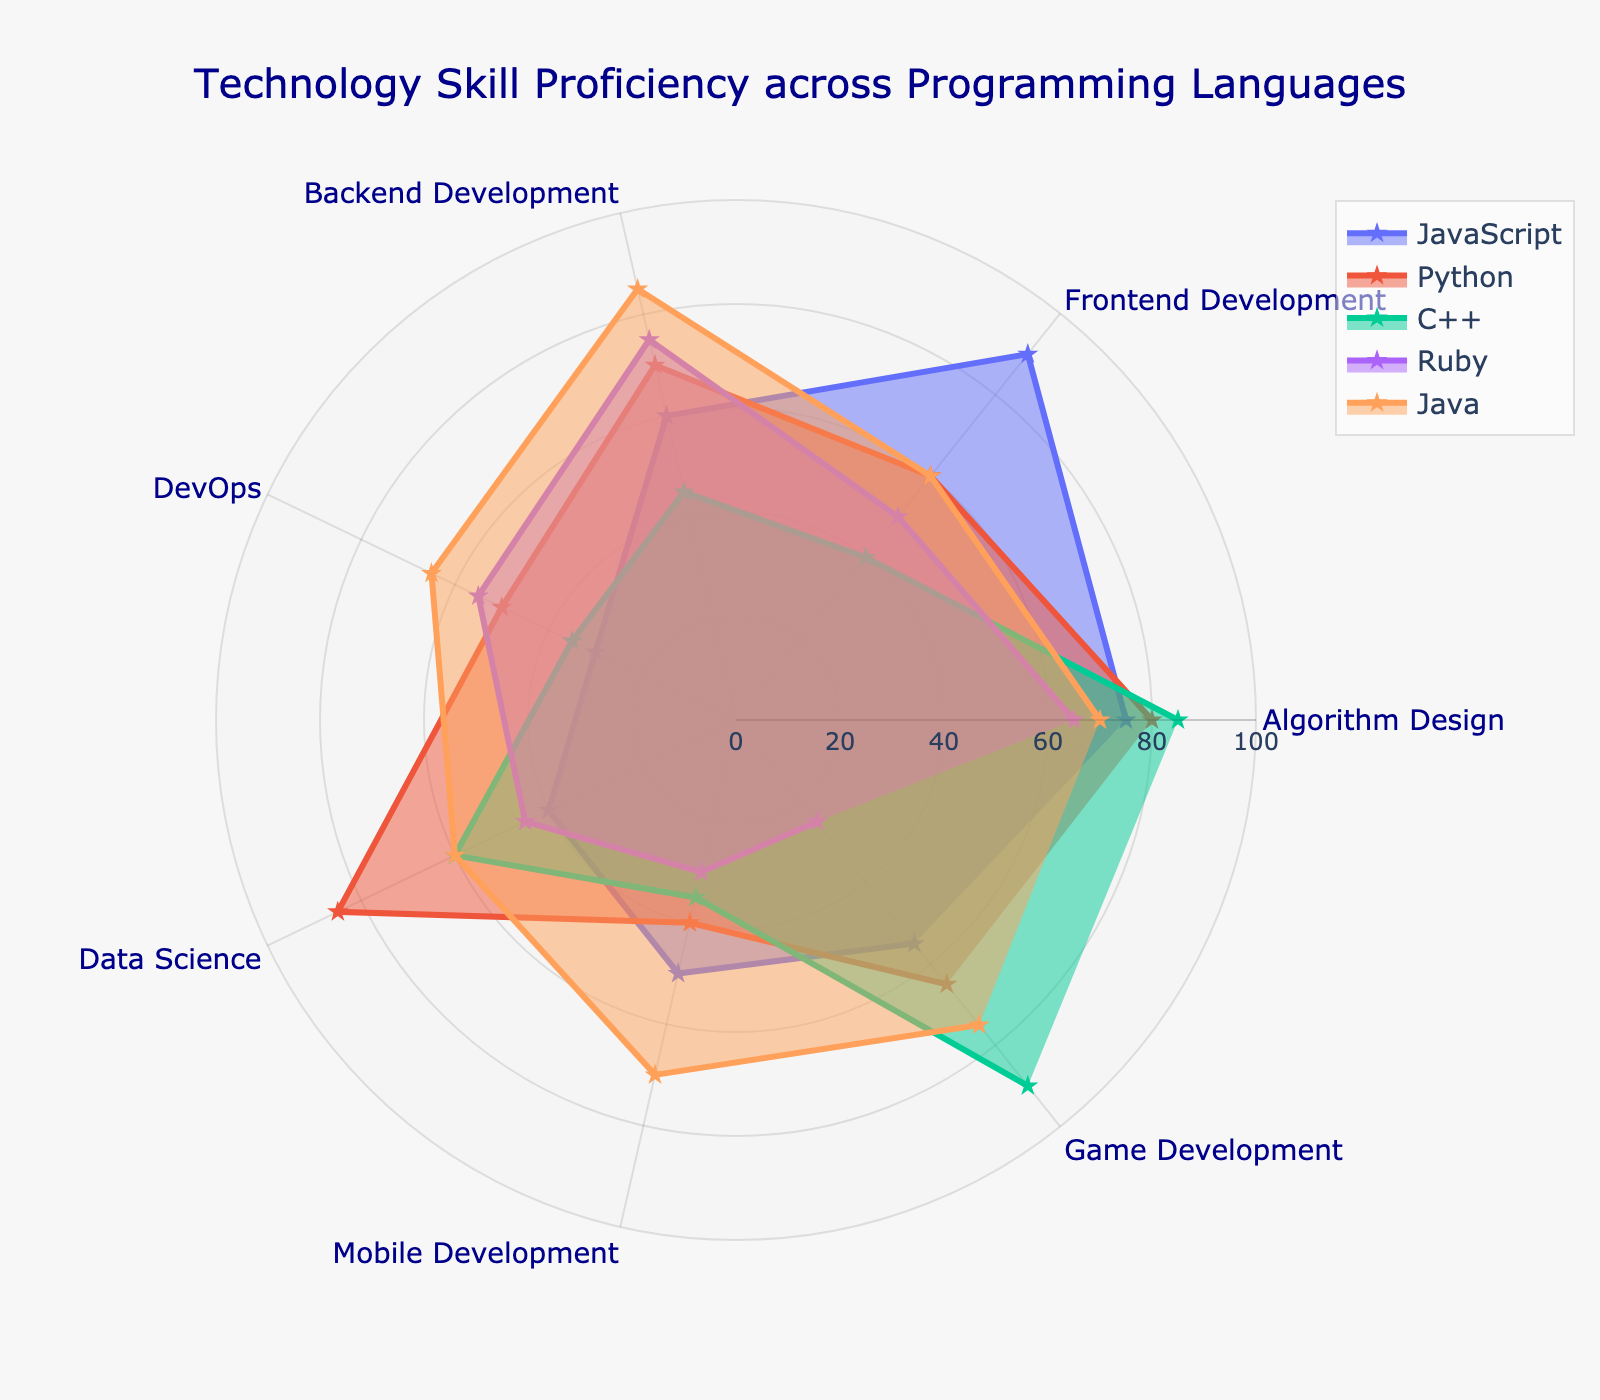What is the title of the radar chart? To determine the title, directly check the text highlighted in the center and top part of the figure.
Answer: Technology Skill Proficiency across Programming Languages Which programming language has the highest frontend development proficiency? Frontend development proficiency is represented along one axis. Identify the programming language that reaches the highest point along this axis.
Answer: JavaScript What is the average proficiency in data science for all the programming languages? Calculate the data science proficiency scores for JavaScript (40), Python (85), C++ (60), Ruby (45), and Java (60). Then, compute the average: (40 + 85 + 60 + 45 + 60) / 5.
Answer: 58 Which language excels more in backend development, Java or Python? Compare the backend development scores for Java (85) and Python (70). Java’s score is higher.
Answer: Java What is the combined proficiency score for JavaScript in mobile and game development? Find the scores for JavaScript in mobile (50) and game development (55). Add the values: 50 + 55.
Answer: 105 Which programming language has the lowest proficiency in DevOps? Find the lowest point along the DevOps axis. JavaScript has a score of 30, Python 50, C++ 35, Ruby 55, and Java 65. The lowest is JavaScript.
Answer: JavaScript In which category does Python have the highest proficiency, and what is the score? Find the category where the Python plot line extends the furthest. It peaks at 85 in Data Science.
Answer: Data Science (85) Order the languages based on their proficiency in algorithm design from highest to lowest. Compare the algorithm design scores: JavaScript (75), Python (80), C++ (85), Ruby (65), Java (70). The order is C++, Python, JavaScript, Java, Ruby.
Answer: C++, Python, JavaScript, Java, Ruby Which programming language is most balanced in its proficiency, showing relatively high scores across all categories? Look for the language whose plot area is evenly spread out and relatively high in all categories. Java appears to have a well-balanced profile with no extreme lows.
Answer: Java How many proficiency categories are displayed on the radar chart? Count the number of different categories listed along the axes of the graph.
Answer: 7 